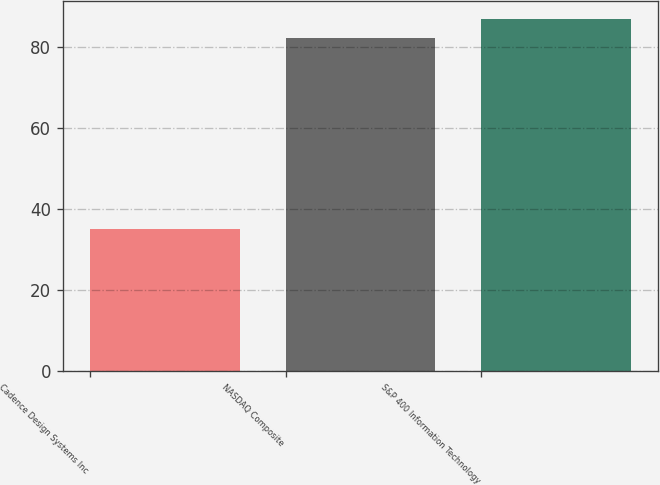Convert chart. <chart><loc_0><loc_0><loc_500><loc_500><bar_chart><fcel>Cadence Design Systems Inc<fcel>NASDAQ Composite<fcel>S&P 400 Information Technology<nl><fcel>35.17<fcel>82.25<fcel>87.01<nl></chart> 